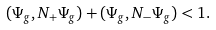<formula> <loc_0><loc_0><loc_500><loc_500>( \Psi _ { g } , N _ { + } \Psi _ { g } ) + ( \Psi _ { g } , N _ { - } \Psi _ { g } ) < 1 .</formula> 